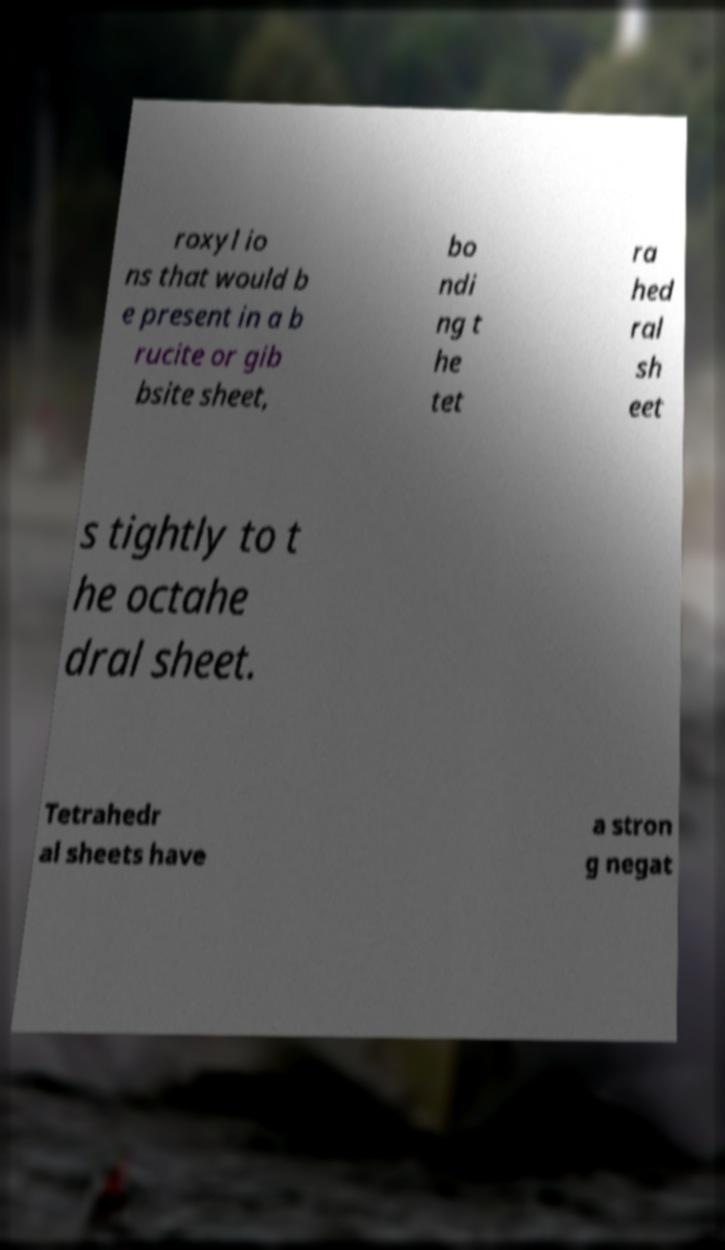For documentation purposes, I need the text within this image transcribed. Could you provide that? roxyl io ns that would b e present in a b rucite or gib bsite sheet, bo ndi ng t he tet ra hed ral sh eet s tightly to t he octahe dral sheet. Tetrahedr al sheets have a stron g negat 